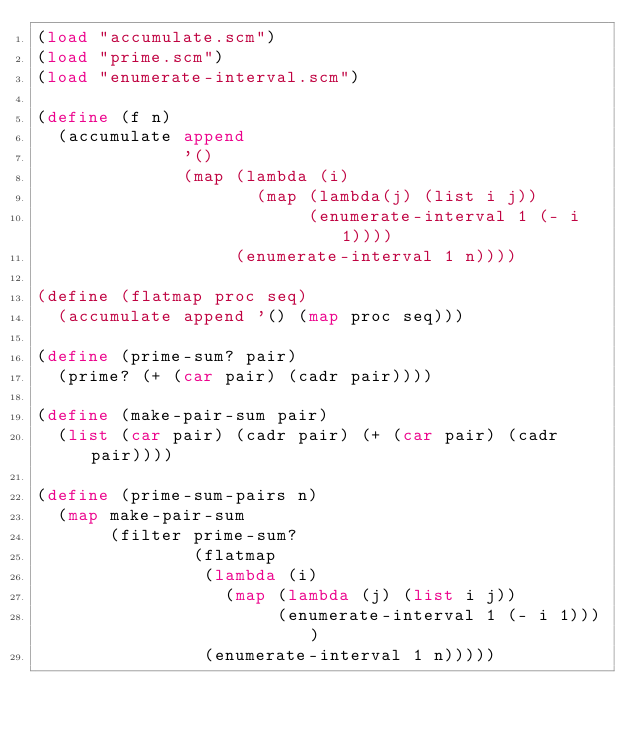<code> <loc_0><loc_0><loc_500><loc_500><_Scheme_>(load "accumulate.scm")
(load "prime.scm")
(load "enumerate-interval.scm")

(define (f n)
  (accumulate append
              '()
              (map (lambda (i)
                     (map (lambda(j) (list i j))
                          (enumerate-interval 1 (- i 1))))
                   (enumerate-interval 1 n))))

(define (flatmap proc seq)
  (accumulate append '() (map proc seq)))

(define (prime-sum? pair)
  (prime? (+ (car pair) (cadr pair))))

(define (make-pair-sum pair)
  (list (car pair) (cadr pair) (+ (car pair) (cadr pair))))

(define (prime-sum-pairs n)
  (map make-pair-sum
       (filter prime-sum?
               (flatmap
                (lambda (i)
                  (map (lambda (j) (list i j))
                       (enumerate-interval 1 (- i 1))))
                (enumerate-interval 1 n)))))</code> 